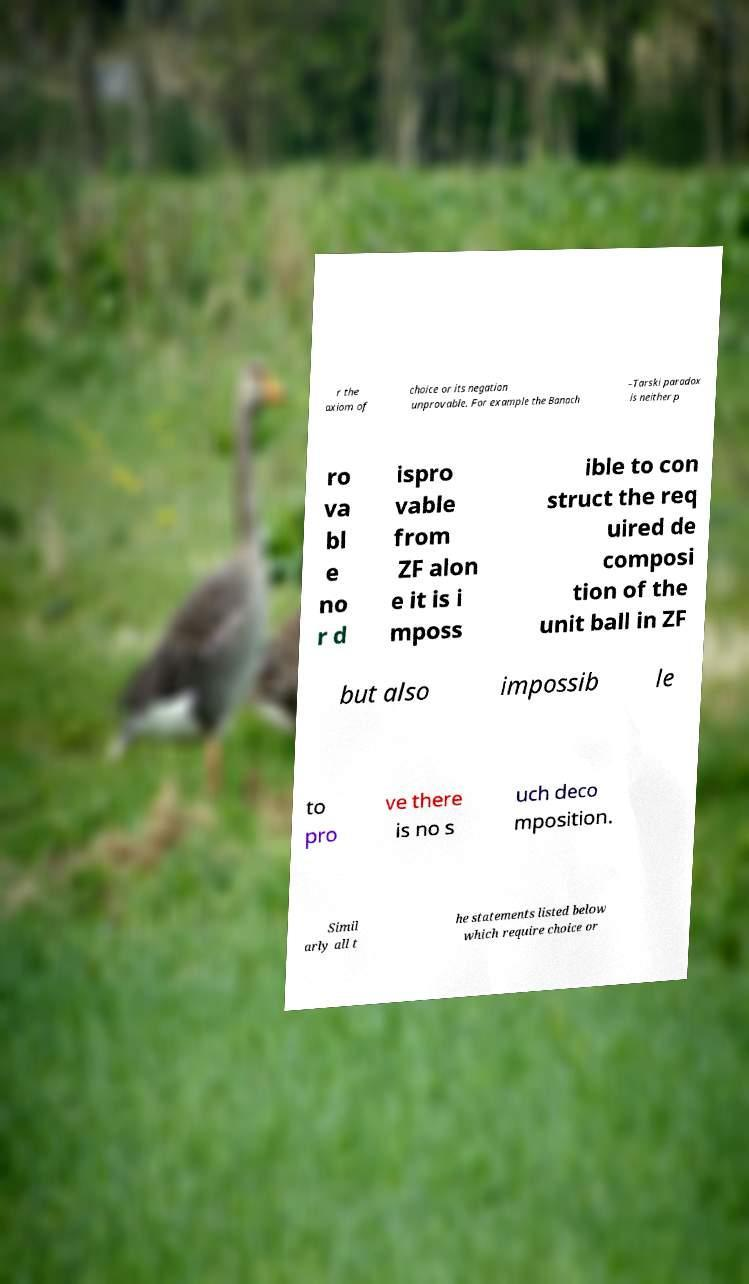Can you accurately transcribe the text from the provided image for me? r the axiom of choice or its negation unprovable. For example the Banach –Tarski paradox is neither p ro va bl e no r d ispro vable from ZF alon e it is i mposs ible to con struct the req uired de composi tion of the unit ball in ZF but also impossib le to pro ve there is no s uch deco mposition. Simil arly all t he statements listed below which require choice or 